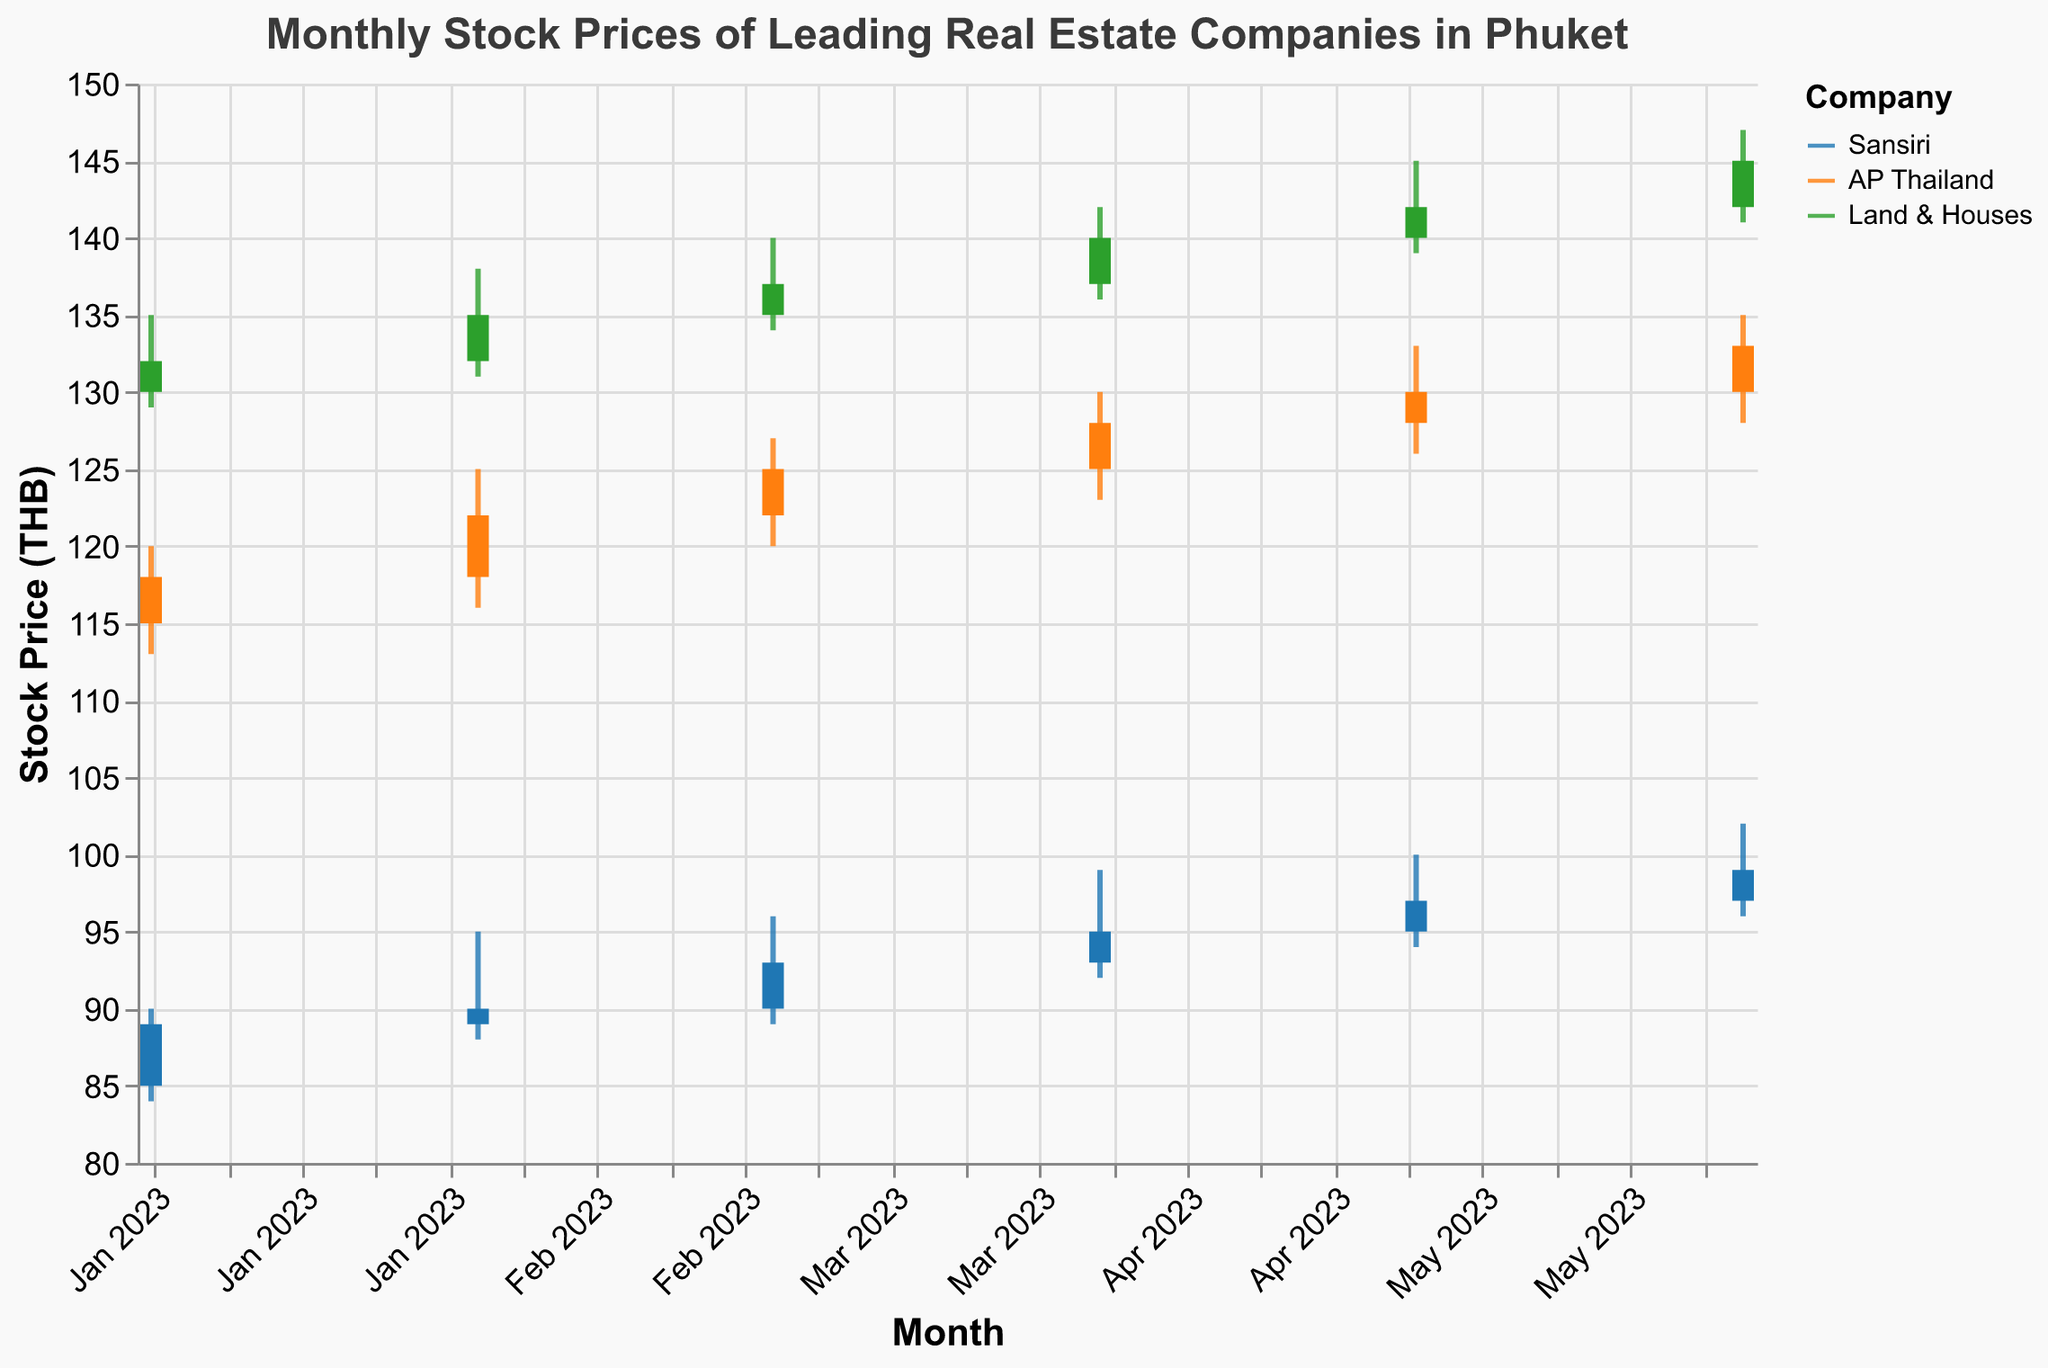Which company had the highest closing stock price in June 2023? To determine this, refer to the data points for June 2023 and compare the closing prices of Sansiri, AP Thailand, and Land & Houses. Land & Houses had the highest closing price of 145 THB.
Answer: Land & Houses Which month had the highest trading volume for Sansiri? To find this, check the trading volumes for Sansiri across all months. The highest trading volume for Sansiri was in June 2023 with a volume of 1,250,000.
Answer: June 2023 What's the difference between the highest and lowest stock prices of AP Thailand in April 2023? For April 2023, AP Thailand's highest stock price was 130 THB and its lowest was 123 THB. The difference is 130 - 123 = 7 THB.
Answer: 7 THB Which company showed a consistent month-over-month increase in closing prices from January to June 2023? To identify this, observe the closing prices for all three companies across each month. Sansiri shows a consistent increase in closing price from 89 THB in January to 99 THB in June.
Answer: Sansiri For Land & Houses, by how much did the closing stock price change from February to March 2023? Land & Houses had a closing stock price of 135 THB in February and 137 THB in March. The change is 137 - 135 = 2 THB.
Answer: 2 THB What is the average closing price for AP Thailand across all months shown? Sum the closing prices for AP Thailand across each month and divide by the number of months. (118+122+125+128+130+133)/6 = 756/6 = 126 THB.
Answer: 126 THB Which company had the smallest range between its highest and lowest stock prices in January 2023? In January 2023, calculate the range for each company. Sansiri: 90-84=6, AP Thailand: 120-113=7, Land & Houses: 135-129=6. Sansiri and Land & Houses have the smallest range of 6.
Answer: Sansiri/Land & Houses What is the total trading volume for Land & Houses across all the months provided? Add up the trading volumes for Land & Houses from each month. (920000 + 950000 + 970000 + 990000 + 1010000 + 1030000) = 5830000.
Answer: 5,830,000 During which month did AP Thailand experience its largest increase in closing price compared to the previous month? Check the differences in closing prices month-by-month. The largest increase is from February to March: 125 - 122 = 3 THB.
Answer: March 2023 By how much did the closing stock price of Land & Houses differ from Sansiri in June 2023? For June 2023, Land & Houses' closing price is 145 THB, and Sansiri's is 99 THB. The difference is 145 - 99 = 46 THB.
Answer: 46 THB 